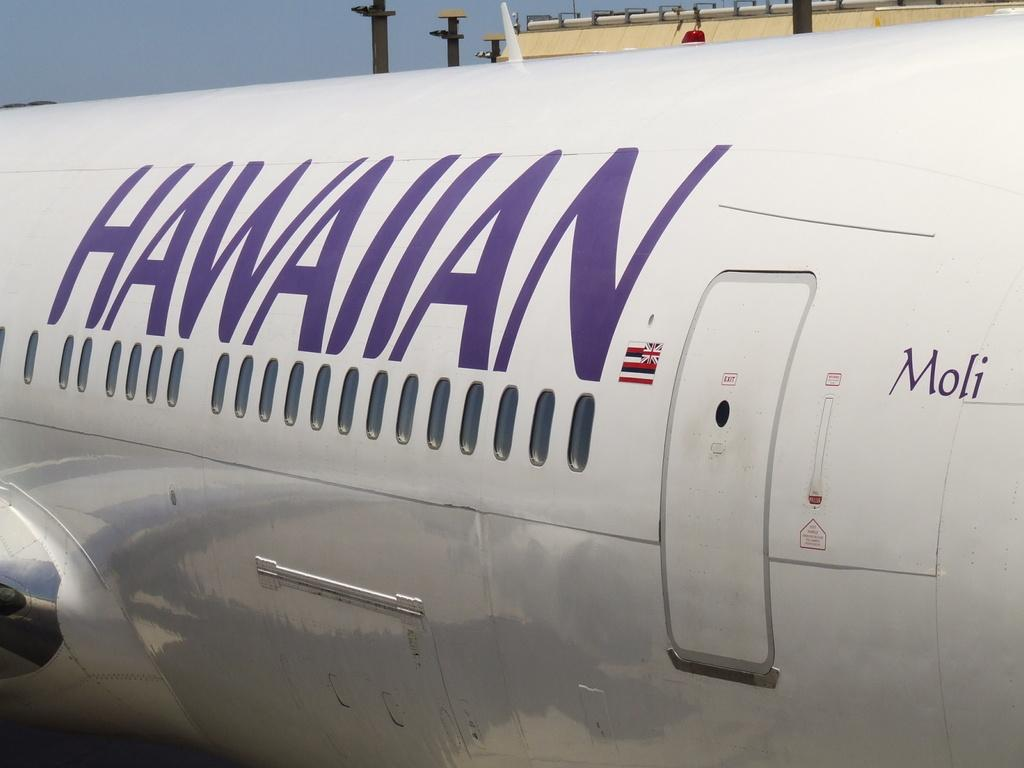What is the main subject in the foreground of the image? There is a truncated airplane in the foreground of the image. What can be seen in the background of the image? There are poles and a building in the background of the image. What is visible in the sky in the image? The sky is visible in the background of the image. How many fingers can be seen pointing at the airplane in the image? There are no fingers visible in the image, as it features a truncated airplane, poles, a building, and the sky. 